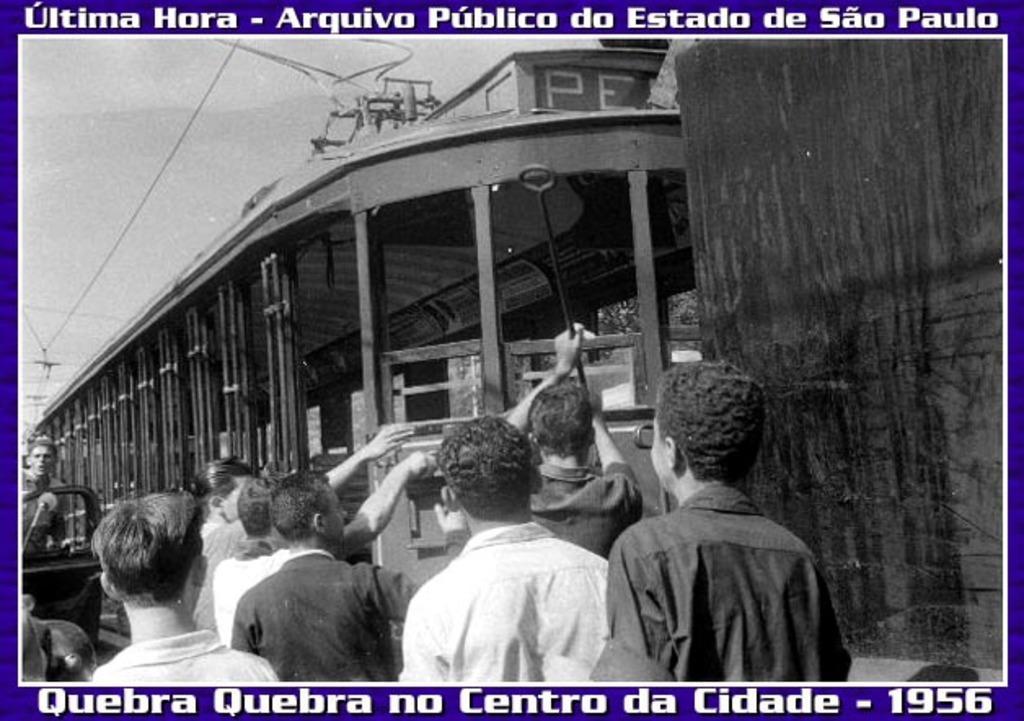How would you summarize this image in a sentence or two? In the image we can see black and white picture of people wearing clothes and vehicle. Here we can see electric wires, metal rod and the sky. 